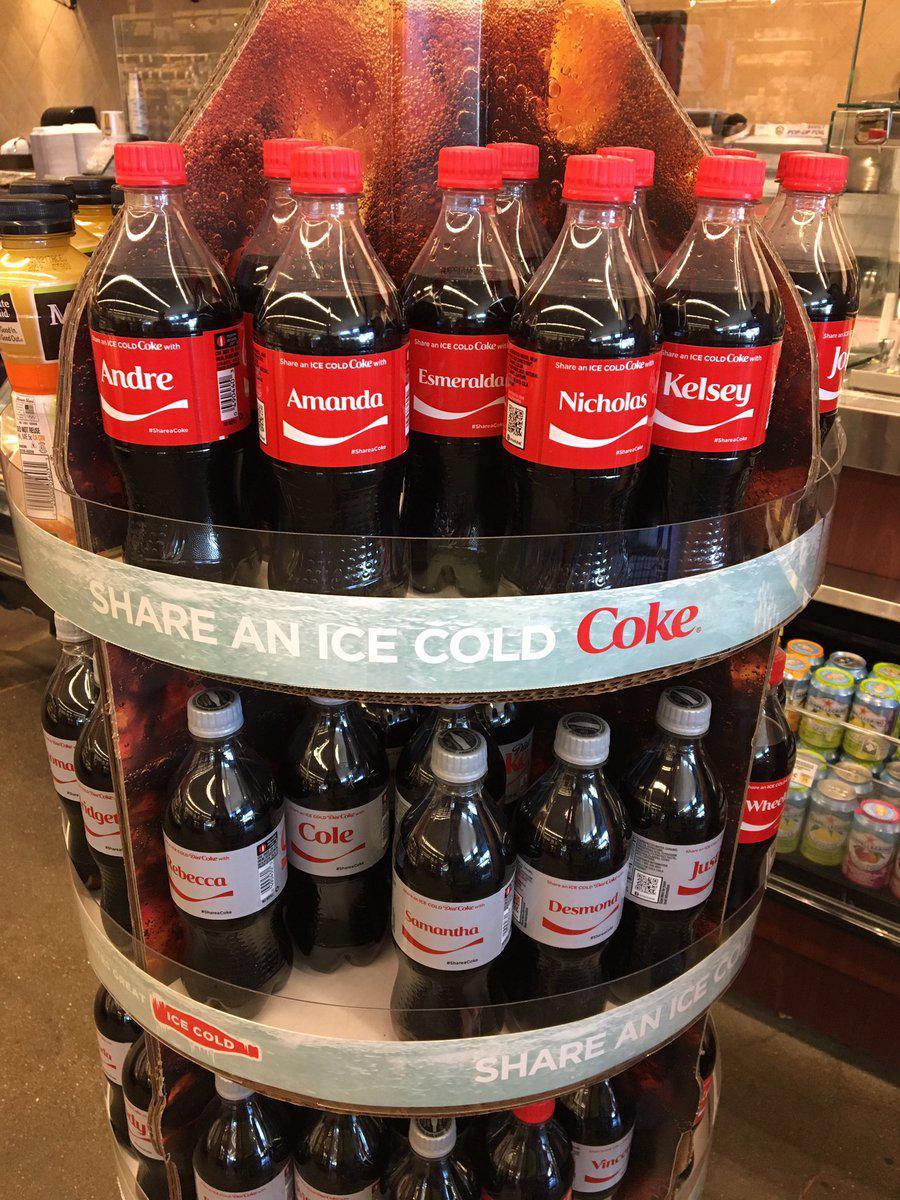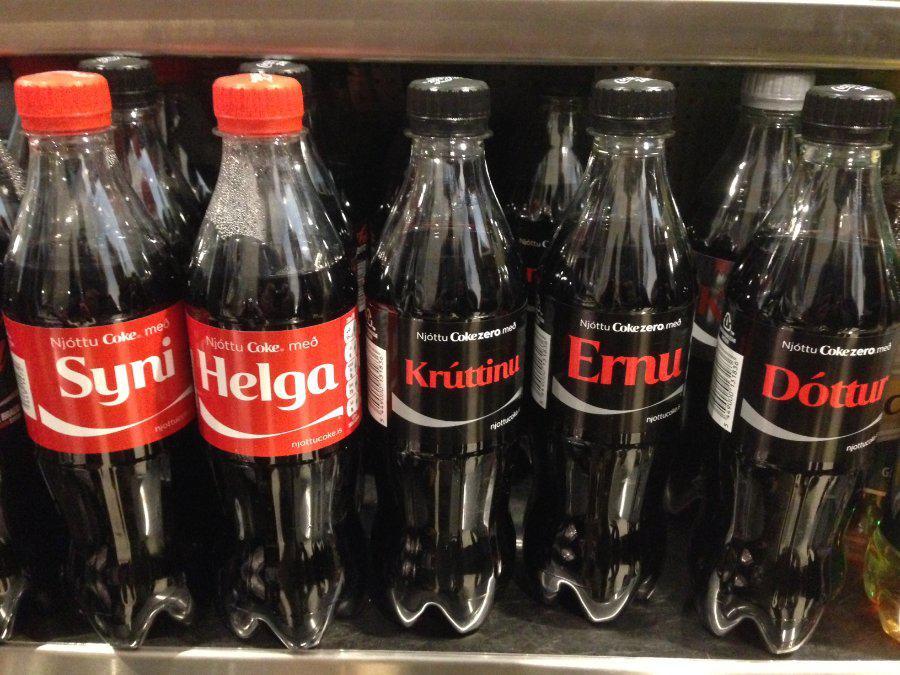The first image is the image on the left, the second image is the image on the right. For the images displayed, is the sentence "IN at least one image there is a display case of at least two shelves holding  sodas." factually correct? Answer yes or no. Yes. The first image is the image on the left, the second image is the image on the right. Examine the images to the left and right. Is the description "There are at most four bottles of soda in one of the images." accurate? Answer yes or no. No. 